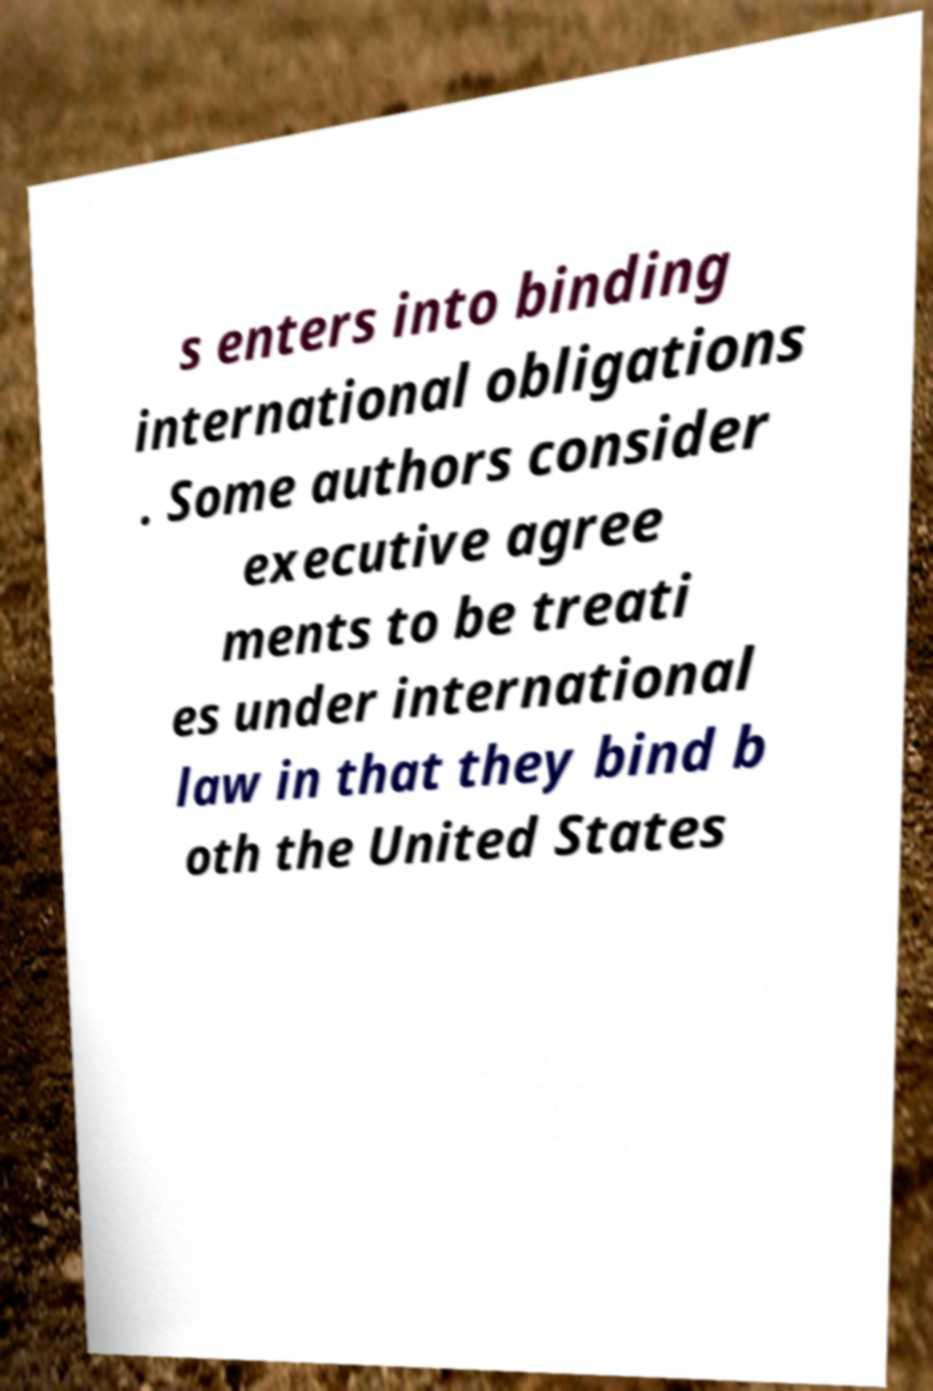Please identify and transcribe the text found in this image. s enters into binding international obligations . Some authors consider executive agree ments to be treati es under international law in that they bind b oth the United States 